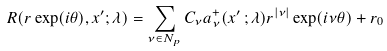Convert formula to latex. <formula><loc_0><loc_0><loc_500><loc_500>R ( r \exp ( i \theta ) , x ^ { \prime } ; \lambda ) = \sum _ { \nu \in N _ { p } } C _ { \nu } a ^ { + } _ { \nu } ( x ^ { \prime } \, ; \lambda ) r ^ { | \nu | } \exp ( i \nu \theta ) + r _ { 0 }</formula> 